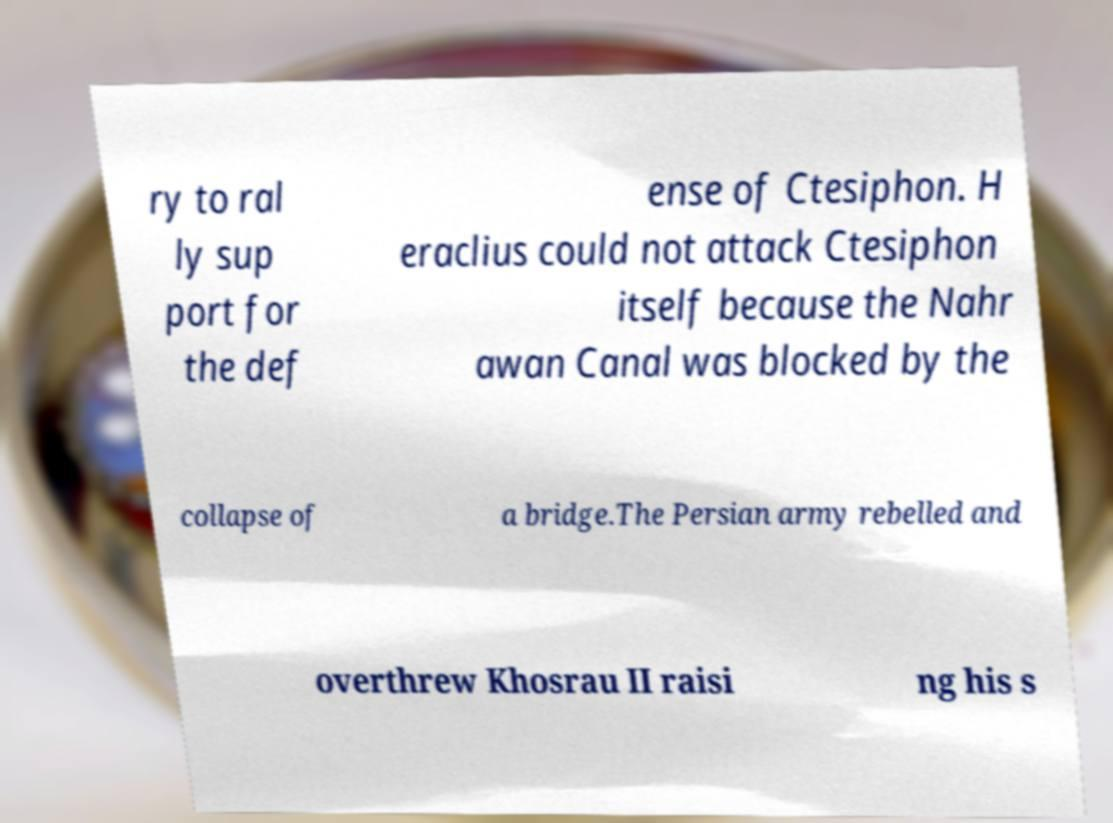Please identify and transcribe the text found in this image. ry to ral ly sup port for the def ense of Ctesiphon. H eraclius could not attack Ctesiphon itself because the Nahr awan Canal was blocked by the collapse of a bridge.The Persian army rebelled and overthrew Khosrau II raisi ng his s 